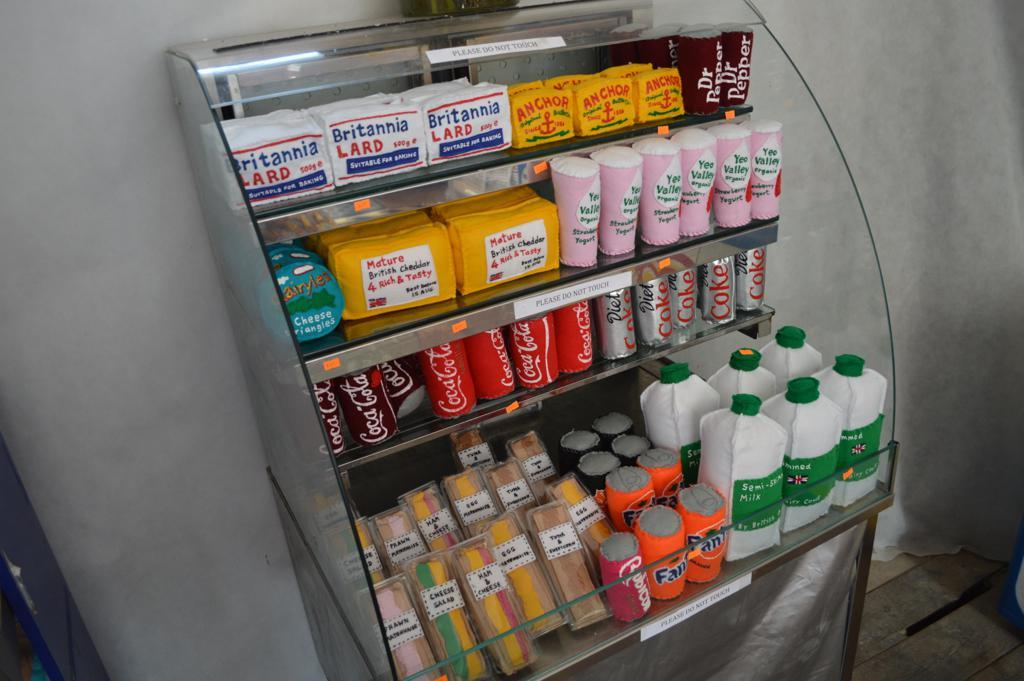<image>
Relay a brief, clear account of the picture shown. a plush display made to look like refrigerated items like Fanta and Cheese Salad sandwich 